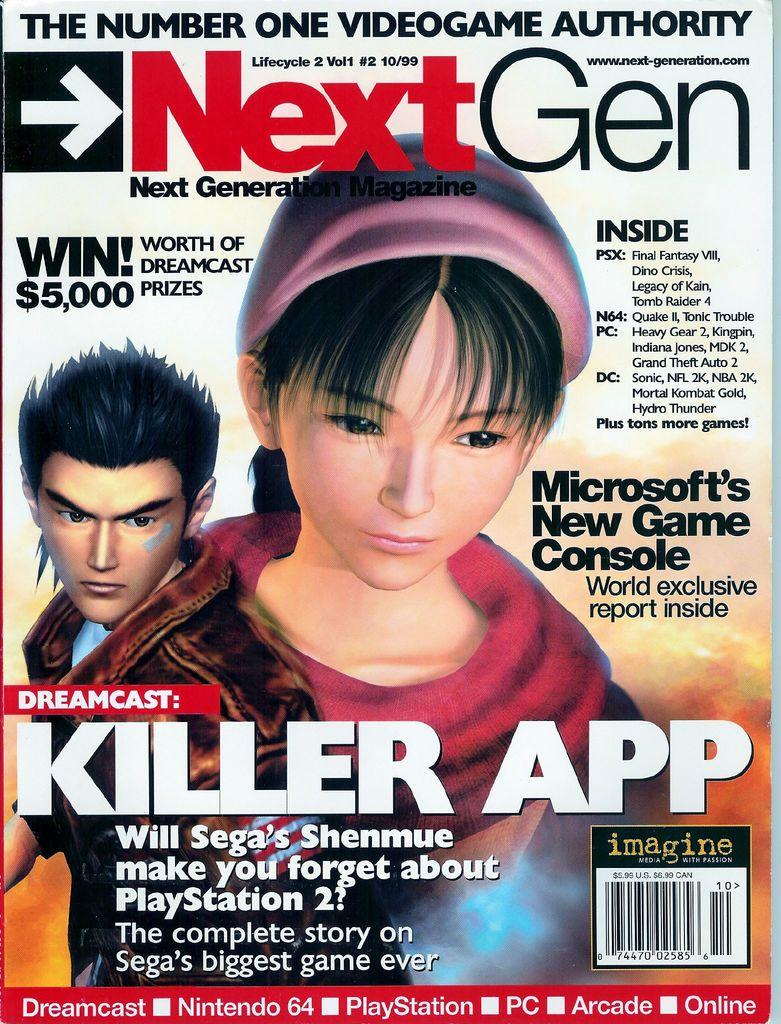What is the main subject of the image? The main subject of the image is a poster. What type of people are depicted on the poster? The poster contains animated people. Is there any text on the poster? Yes, there is text written on the poster. What type of comb is used to style the animated people's hair on the poster? There is no comb present in the image, and the animated people's hair is not being styled. 